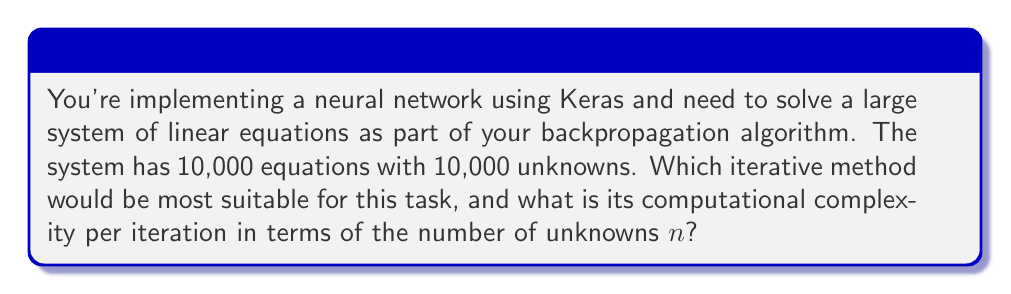Show me your answer to this math problem. For a large system of linear equations in machine learning contexts, the Conjugate Gradient (CG) method is often the most suitable iterative method. Let's break down why and examine its complexity:

1. Suitability for machine learning:
   - CG is particularly effective for sparse, symmetric positive-definite matrices, which are common in neural network computations.
   - It converges faster than simpler methods like Jacobi or Gauss-Seidel for well-conditioned systems.

2. Computational complexity:
   - The main operations in each CG iteration are:
     a. Matrix-vector multiplication: $O(n^2)$ for dense matrices, but often $O(n)$ for sparse matrices in neural networks.
     b. Vector operations (additions, dot products): $O(n)$
   - Therefore, the overall complexity per iteration is $O(n^2)$ for dense matrices or $O(n)$ for sparse matrices.

3. Comparison with direct methods:
   - Direct methods like Gaussian elimination have $O(n^3)$ complexity.
   - For n = 10,000, iterative methods are significantly faster per iteration.

4. Convergence:
   - CG theoretically converges in at most n iterations for exact arithmetic.
   - In practice, due to round-off errors, it may require more iterations but still converges faster than the theoretical bound.

5. Implementation in Scipy:
   - Scipy provides `scipy.sparse.linalg.cg` for the Conjugate Gradient method, which can be easily integrated with Keras models.

Given the large size of the system (10,000 x 10,000) and the context of neural networks, where matrices are often sparse, the Conjugate Gradient method with $O(n)$ complexity per iteration is the most suitable choice.
Answer: Conjugate Gradient method, $O(n)$ per iteration for sparse matrices 